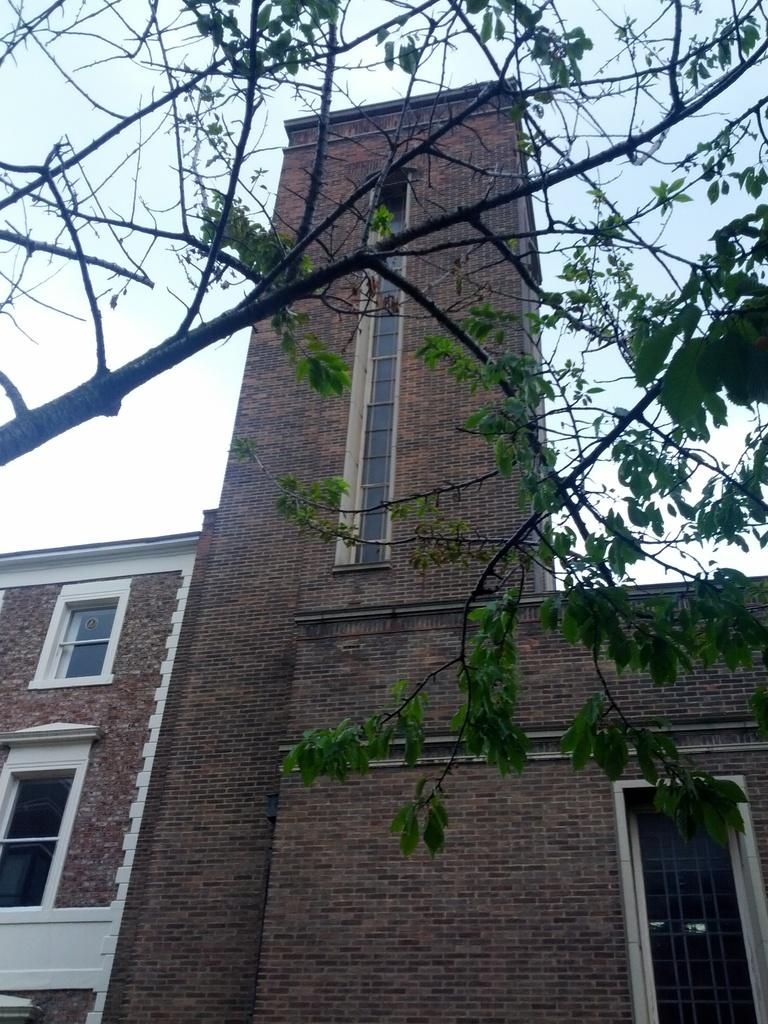What type of structure is present in the image? There is a building in the image. What is the color of the building? The building is brown in color. What can be seen at the top of the image besides the building? There is a tree and the sky visible at the top of the image. How many oranges are hanging from the tree in the image? There are no oranges visible in the image, as the tree is not close enough to determine the type of fruit it may have. 